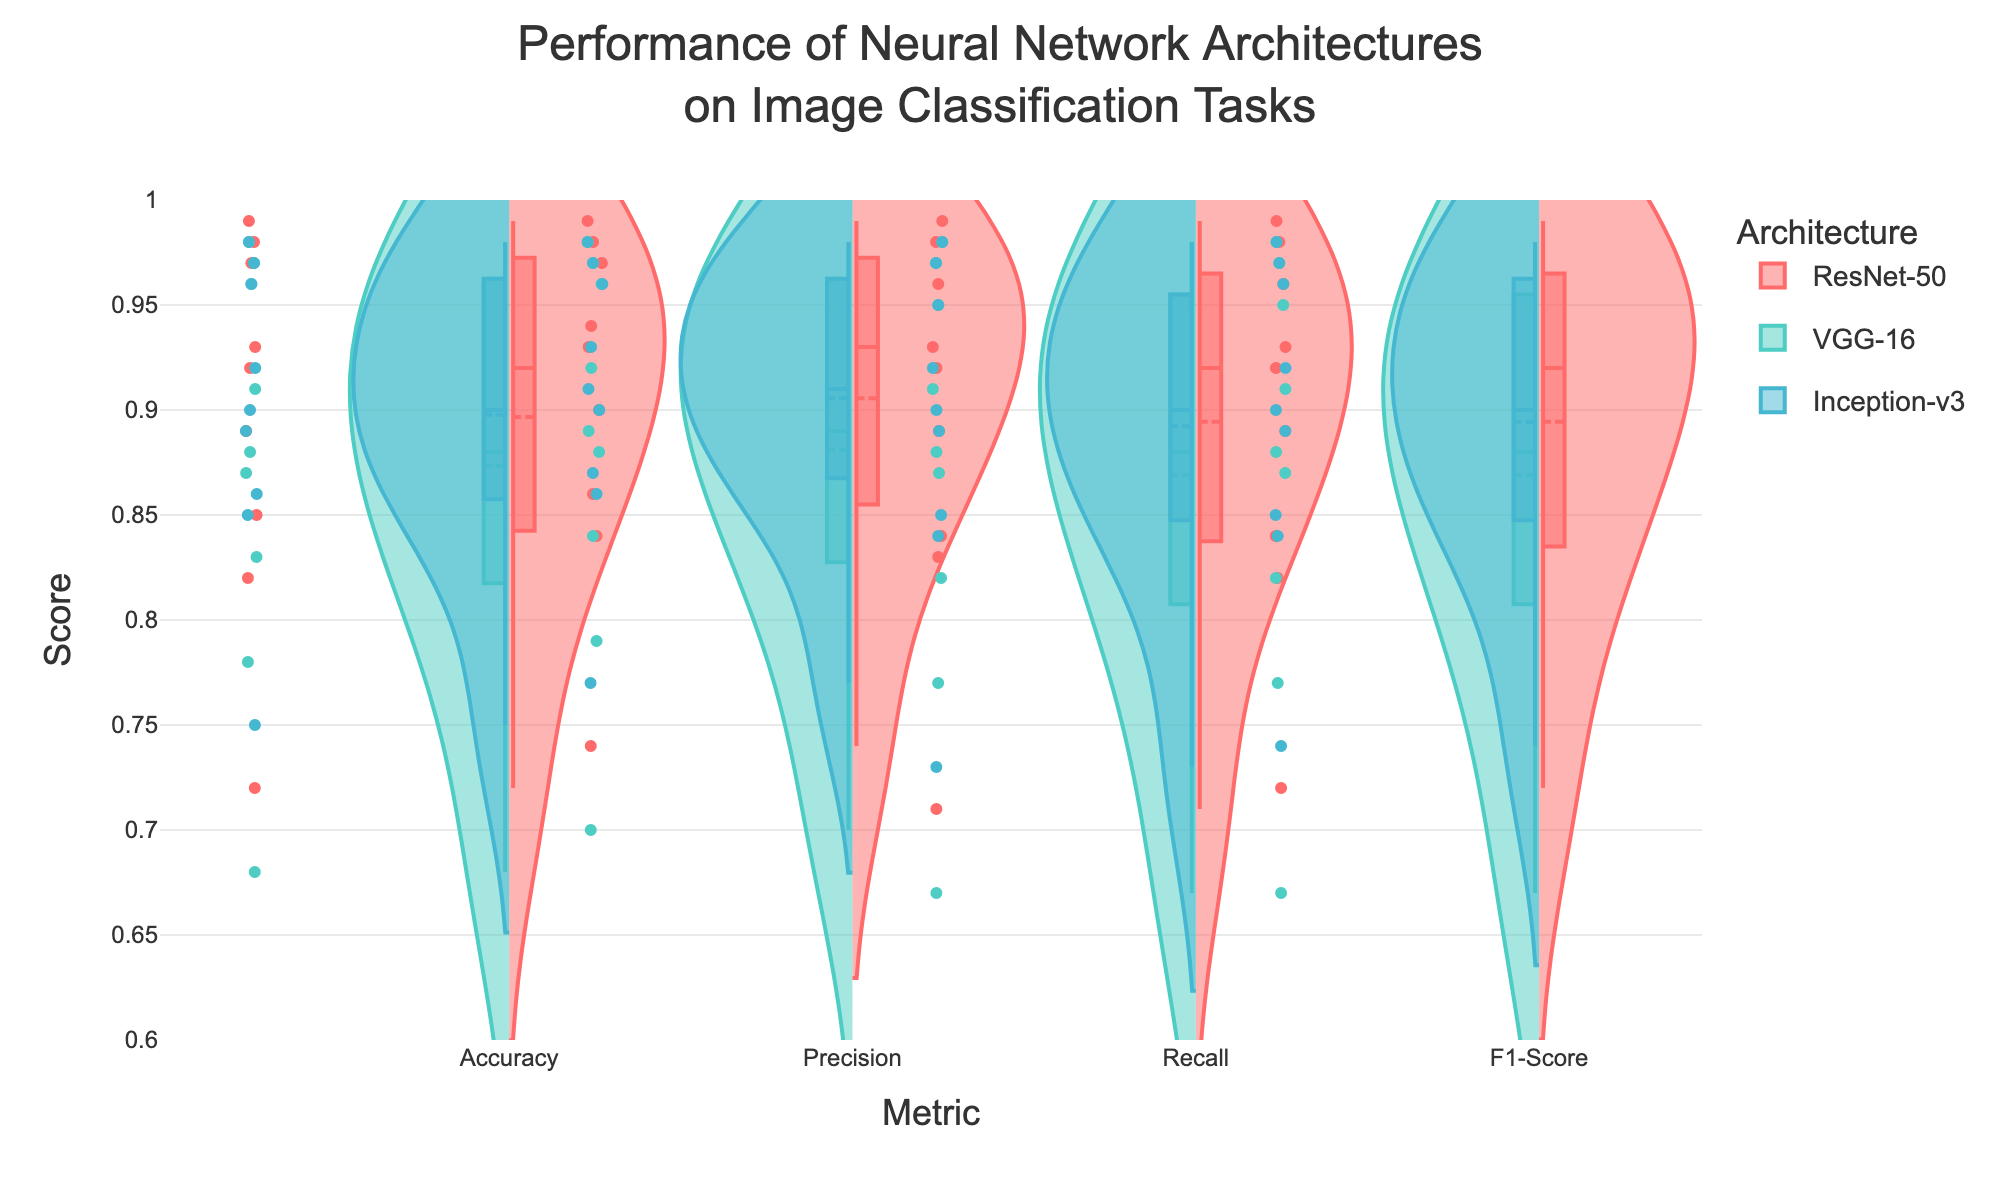What is the title of the figure? The title is located at the top of the figure and usually describes the main content or purpose of the visualization.
Answer: Performance of Neural Network Architectures on Image Classification Tasks Which architecture has the highest Precision score on CIFAR-10 with a dataset size of 5000? To find this, look at the Precision scores for the CIFAR-10 dataset and identify the data points for each architecture at a dataset size of 5000. Compare the scores to see which is the highest.
Answer: ResNet-50 How does the Accuracy of VGG-16 on MNIST dataset change with increasing dataset size? To determine this, observe the Accuracy scores for VGG-16 on the MNIST dataset at different dataset sizes and note the changes.
Answer: It increases What is the overall trend for Recall scores across different architectures when the dataset size is 10000? Compare the Recall scores of different architectures for datasets with a size of 10000 without differentiating by dataset type. We should observe if the scores generally increase, decrease, or stay the same.
Answer: They generally increase Which metric shows the most significant variation across different architectures? To answer this, observe the width and spread of the violin plots for each metric. The metric with the widest plots or more dispersed data points indicates greater variation.
Answer: Accuracy Does Inception-v3 consistently outperform VGG-16 across all datasets and metrics? Check the violin plots for each dataset and metric, contrasting Inception-v3 with VGG-16 to see if Inception-v3 has higher values in every case.
Answer: No What can be inferred about ResNet-50's F1-Score in comparison to its Recall and Precision? Look at the violin plots of ResNet-50 for Recall, Precision, and F1-Score. Since F1-Score is the harmonic mean of Precision and Recall, it should lie between the two. Compare their positions.
Answer: F1-Score is generally close to both Precision and Recall Which architecture has the narrowest spread in scores for any given metric? Examine the violin plots to see which architecture has the most compact or narrow violin plots for any single metric, indicating least variation.
Answer: ResNet-50 What is the average F1-Score for VGG-16 across all dataset sizes on Fashion-MNIST? To find this average, sum the F1-Scores of VGG-16 for Fashion-MNIST across the different dataset sizes and divide by the number of data points.
Answer: 0.867 